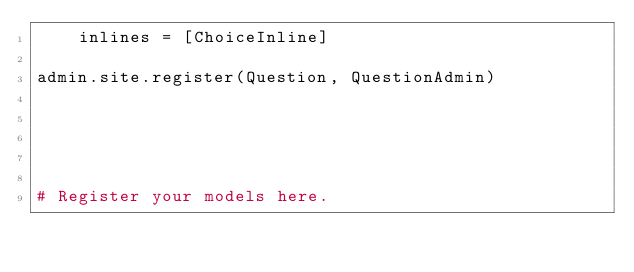<code> <loc_0><loc_0><loc_500><loc_500><_Python_>    inlines = [ChoiceInline]

admin.site.register(Question, QuestionAdmin)





# Register your models here.
</code> 